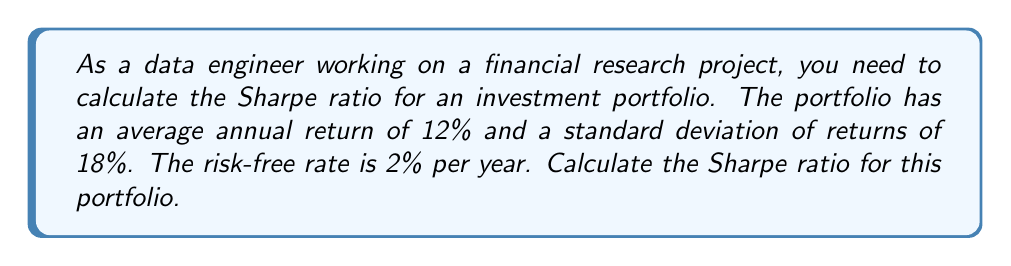Provide a solution to this math problem. To calculate the Sharpe ratio, we need to follow these steps:

1. Understand the components:
   - $R_p$: Average annual return of the portfolio = 12%
   - $R_f$: Risk-free rate = 2%
   - $\sigma_p$: Standard deviation of portfolio returns = 18%

2. Calculate the excess return:
   Excess return = $R_p - R_f$ = 12% - 2% = 10%

3. Apply the Sharpe ratio formula:
   The Sharpe ratio is defined as:

   $$\text{Sharpe Ratio} = \frac{R_p - R_f}{\sigma_p}$$

   Where:
   $R_p - R_f$ is the excess return
   $\sigma_p$ is the standard deviation of portfolio returns

4. Substitute the values into the formula:

   $$\text{Sharpe Ratio} = \frac{10\%}{18\%} = \frac{0.10}{0.18}$$

5. Perform the calculation:

   $$\text{Sharpe Ratio} = 0.5556$$

The Sharpe ratio of 0.5556 indicates the risk-adjusted performance of the portfolio. A higher Sharpe ratio suggests better risk-adjusted returns. This value can be used to compare the performance of different portfolios or investment strategies in your financial research database.
Answer: The Sharpe ratio for the given investment portfolio is 0.5556. 